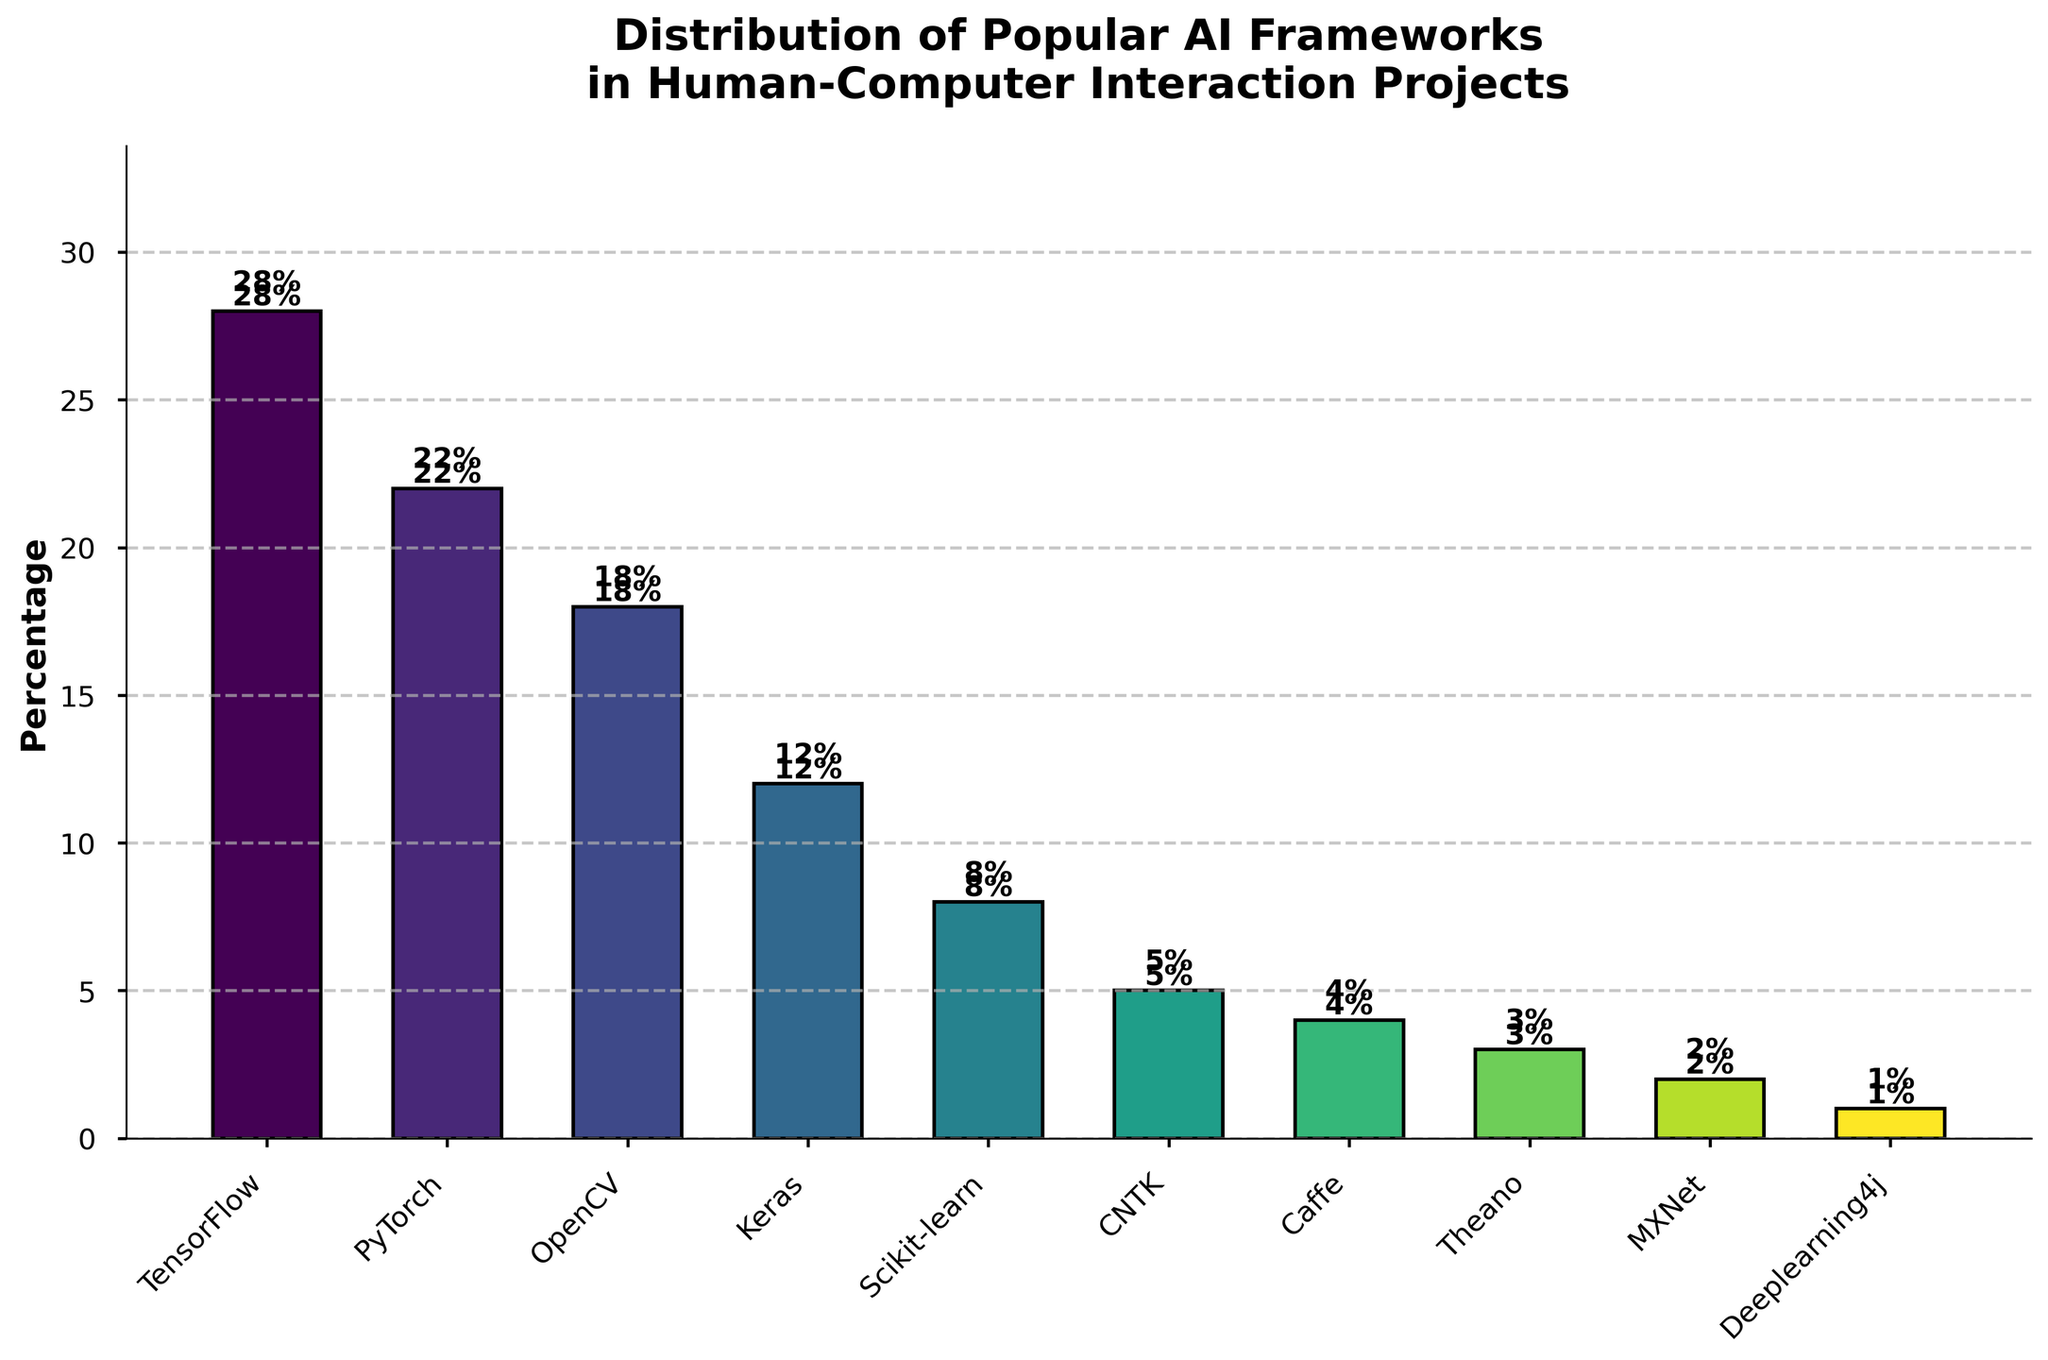Which AI framework has the highest usage percentage? The bar chart clearly shows the height of each bar representing the percentage usage. TensorFlow has the tallest bar.
Answer: TensorFlow How many frameworks have a usage percentage greater than or equal to 10%? By inspecting the heights of the bars, we see TensorFlow, PyTorch, OpenCV, and Keras each have a percentage of 10% or greater. That's four frameworks.
Answer: 4 What is the combined usage percentage of TensorFlow, PyTorch, and Keras? Adding the percentages of these frameworks: TensorFlow (28%) + PyTorch (22%) + Keras (12%) = 62%.
Answer: 62% Which framework has a lower usage percentage, OpenCV or Scikit-learn, and by how much? OpenCV has a usage percentage of 18%, while Scikit-learn has 8%. The difference is 18% - 8% = 10%.
Answer: Scikit-learn by 10% What is the average usage percentage of the bottom three frameworks? The bottom three frameworks are Theano (3%), MXNet (2%), and Deeplearning4j (1%). Their average percentage is (3% + 2% + 1%) / 3 = 2%.
Answer: 2% How does the usage percentage of PyTorch compare to the total of Caffe, CNTK, and Theano? Summing up Caffe (4%), CNTK (5%), and Theano (3%) gives 4% + 5% + 3% = 12%. PyTorch has a usage percentage of 22%, which is greater.
Answer: PyTorch is greater Describe the visual difference between the bar heights of TensorFlow and MXNet. TensorFlow's bar is the tallest and MXNet’s is among the shortest. Visually, TensorFlow's bar reaches the top of the y-axis at 28%, while MXNet's bar barely rises to 2%.
Answer: TensorFlow much taller What's the difference in usage percentage between the most used and the least used frameworks? The most used is TensorFlow at 28%, and the least used is Deeplearning4j at 1%. The difference is 28% - 1% = 27%.
Answer: 27% Identify the framework with the third highest usage percentage and provide its value. By ordering the bars’ heights, the third highest is OpenCV, which has a percentage of 18%.
Answer: OpenCV with 18% How many frameworks have a percentage that is lower than the average percentage usage across all frameworks? To find the average: sum all percentages (28+22+18+12+8+5+4+3+2+1=103), then divide by 10 frameworks: 103/10 = 10.3%. Frameworks below this average are Scikit-learn, CNTK, Caffe, Theano, MXNet, and Deeplearning4j; totaling to six frameworks.
Answer: 6 